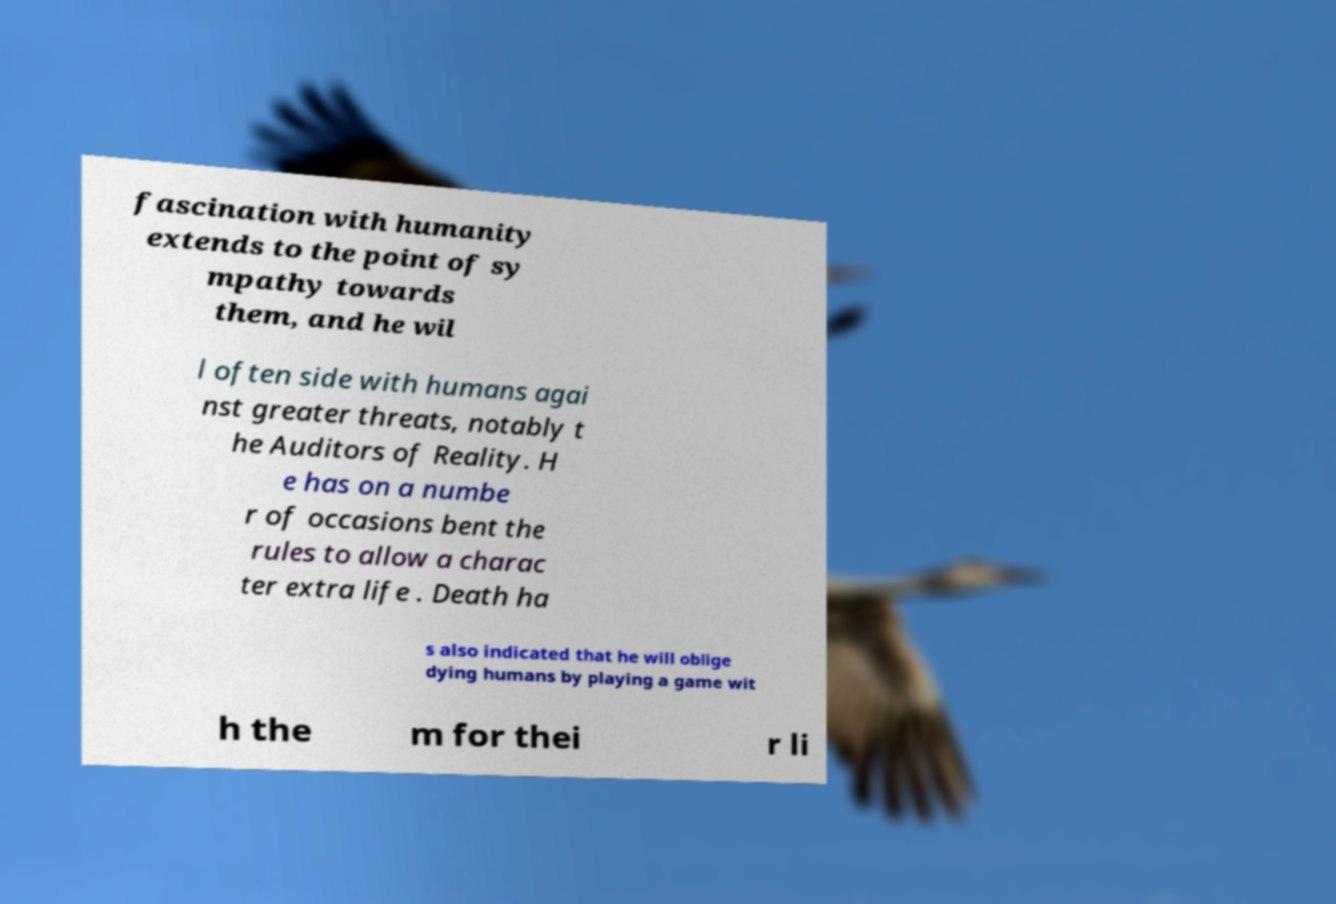Could you extract and type out the text from this image? fascination with humanity extends to the point of sy mpathy towards them, and he wil l often side with humans agai nst greater threats, notably t he Auditors of Reality. H e has on a numbe r of occasions bent the rules to allow a charac ter extra life . Death ha s also indicated that he will oblige dying humans by playing a game wit h the m for thei r li 